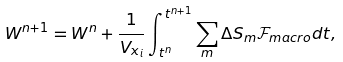Convert formula to latex. <formula><loc_0><loc_0><loc_500><loc_500>W ^ { n + 1 } = W ^ { n } + \frac { 1 } { V _ { x _ { i } } } \int _ { t ^ { n } } ^ { t ^ { n + 1 } } \sum _ { m } \Delta S _ { m } \mathcal { F } _ { m a c r o } d t ,</formula> 